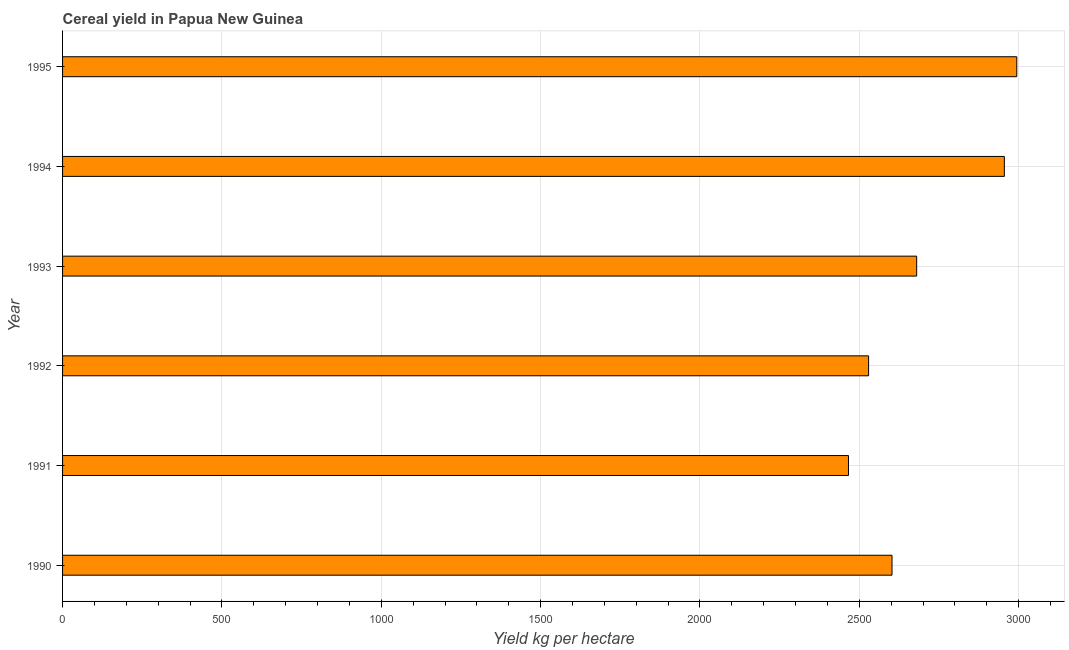Does the graph contain grids?
Make the answer very short. Yes. What is the title of the graph?
Keep it short and to the point. Cereal yield in Papua New Guinea. What is the label or title of the X-axis?
Your answer should be very brief. Yield kg per hectare. What is the cereal yield in 1995?
Give a very brief answer. 2994.13. Across all years, what is the maximum cereal yield?
Offer a very short reply. 2994.13. Across all years, what is the minimum cereal yield?
Offer a very short reply. 2466.04. In which year was the cereal yield maximum?
Make the answer very short. 1995. What is the sum of the cereal yield?
Provide a short and direct response. 1.62e+04. What is the difference between the cereal yield in 1990 and 1994?
Ensure brevity in your answer.  -352.48. What is the average cereal yield per year?
Offer a terse response. 2704.52. What is the median cereal yield?
Ensure brevity in your answer.  2641.33. In how many years, is the cereal yield greater than 2200 kg per hectare?
Your answer should be compact. 6. What is the ratio of the cereal yield in 1990 to that in 1994?
Your answer should be very brief. 0.88. Is the cereal yield in 1990 less than that in 1995?
Your response must be concise. Yes. Is the difference between the cereal yield in 1990 and 1995 greater than the difference between any two years?
Your answer should be compact. No. What is the difference between the highest and the second highest cereal yield?
Make the answer very short. 38.99. Is the sum of the cereal yield in 1990 and 1991 greater than the maximum cereal yield across all years?
Give a very brief answer. Yes. What is the difference between the highest and the lowest cereal yield?
Your answer should be compact. 528.09. In how many years, is the cereal yield greater than the average cereal yield taken over all years?
Offer a very short reply. 2. How many bars are there?
Ensure brevity in your answer.  6. Are all the bars in the graph horizontal?
Give a very brief answer. Yes. How many years are there in the graph?
Give a very brief answer. 6. Are the values on the major ticks of X-axis written in scientific E-notation?
Your answer should be very brief. No. What is the Yield kg per hectare in 1990?
Ensure brevity in your answer.  2602.65. What is the Yield kg per hectare of 1991?
Your response must be concise. 2466.04. What is the Yield kg per hectare in 1992?
Provide a succinct answer. 2529.16. What is the Yield kg per hectare in 1993?
Give a very brief answer. 2680. What is the Yield kg per hectare in 1994?
Keep it short and to the point. 2955.13. What is the Yield kg per hectare of 1995?
Keep it short and to the point. 2994.13. What is the difference between the Yield kg per hectare in 1990 and 1991?
Provide a succinct answer. 136.61. What is the difference between the Yield kg per hectare in 1990 and 1992?
Ensure brevity in your answer.  73.49. What is the difference between the Yield kg per hectare in 1990 and 1993?
Your answer should be compact. -77.35. What is the difference between the Yield kg per hectare in 1990 and 1994?
Provide a short and direct response. -352.48. What is the difference between the Yield kg per hectare in 1990 and 1995?
Ensure brevity in your answer.  -391.48. What is the difference between the Yield kg per hectare in 1991 and 1992?
Offer a very short reply. -63.12. What is the difference between the Yield kg per hectare in 1991 and 1993?
Ensure brevity in your answer.  -213.96. What is the difference between the Yield kg per hectare in 1991 and 1994?
Your answer should be compact. -489.09. What is the difference between the Yield kg per hectare in 1991 and 1995?
Your answer should be very brief. -528.09. What is the difference between the Yield kg per hectare in 1992 and 1993?
Provide a succinct answer. -150.84. What is the difference between the Yield kg per hectare in 1992 and 1994?
Provide a succinct answer. -425.97. What is the difference between the Yield kg per hectare in 1992 and 1995?
Make the answer very short. -464.96. What is the difference between the Yield kg per hectare in 1993 and 1994?
Make the answer very short. -275.13. What is the difference between the Yield kg per hectare in 1993 and 1995?
Provide a succinct answer. -314.13. What is the difference between the Yield kg per hectare in 1994 and 1995?
Your answer should be compact. -38.99. What is the ratio of the Yield kg per hectare in 1990 to that in 1991?
Provide a succinct answer. 1.05. What is the ratio of the Yield kg per hectare in 1990 to that in 1993?
Offer a very short reply. 0.97. What is the ratio of the Yield kg per hectare in 1990 to that in 1994?
Your answer should be compact. 0.88. What is the ratio of the Yield kg per hectare in 1990 to that in 1995?
Your answer should be very brief. 0.87. What is the ratio of the Yield kg per hectare in 1991 to that in 1994?
Ensure brevity in your answer.  0.83. What is the ratio of the Yield kg per hectare in 1991 to that in 1995?
Ensure brevity in your answer.  0.82. What is the ratio of the Yield kg per hectare in 1992 to that in 1993?
Your answer should be compact. 0.94. What is the ratio of the Yield kg per hectare in 1992 to that in 1994?
Your answer should be very brief. 0.86. What is the ratio of the Yield kg per hectare in 1992 to that in 1995?
Offer a very short reply. 0.84. What is the ratio of the Yield kg per hectare in 1993 to that in 1994?
Ensure brevity in your answer.  0.91. What is the ratio of the Yield kg per hectare in 1993 to that in 1995?
Provide a succinct answer. 0.9. What is the ratio of the Yield kg per hectare in 1994 to that in 1995?
Your answer should be compact. 0.99. 